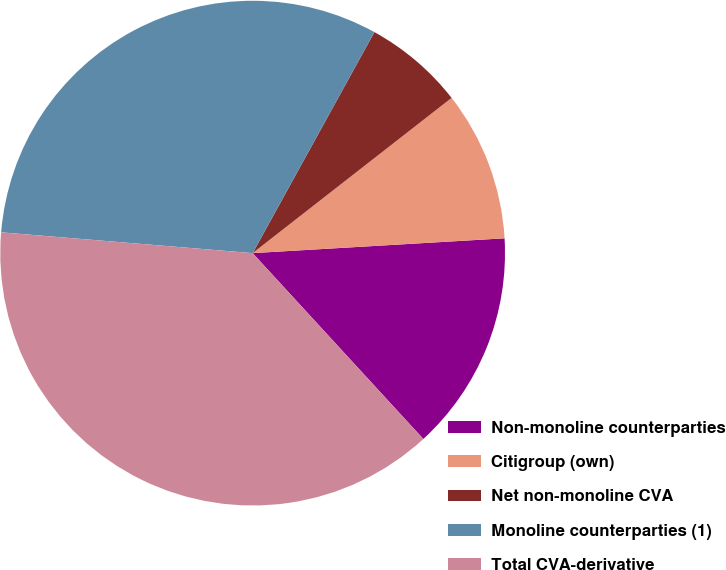Convert chart. <chart><loc_0><loc_0><loc_500><loc_500><pie_chart><fcel>Non-monoline counterparties<fcel>Citigroup (own)<fcel>Net non-monoline CVA<fcel>Monoline counterparties (1)<fcel>Total CVA-derivative<nl><fcel>14.11%<fcel>9.61%<fcel>6.44%<fcel>31.7%<fcel>38.14%<nl></chart> 